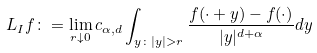<formula> <loc_0><loc_0><loc_500><loc_500>L _ { I } f \colon = \lim _ { r \downarrow 0 } c _ { \alpha , d } \int _ { y \colon | y | > r } \frac { f ( \cdot + y ) - f ( \cdot ) } { | y | ^ { d + \alpha } } d y</formula> 